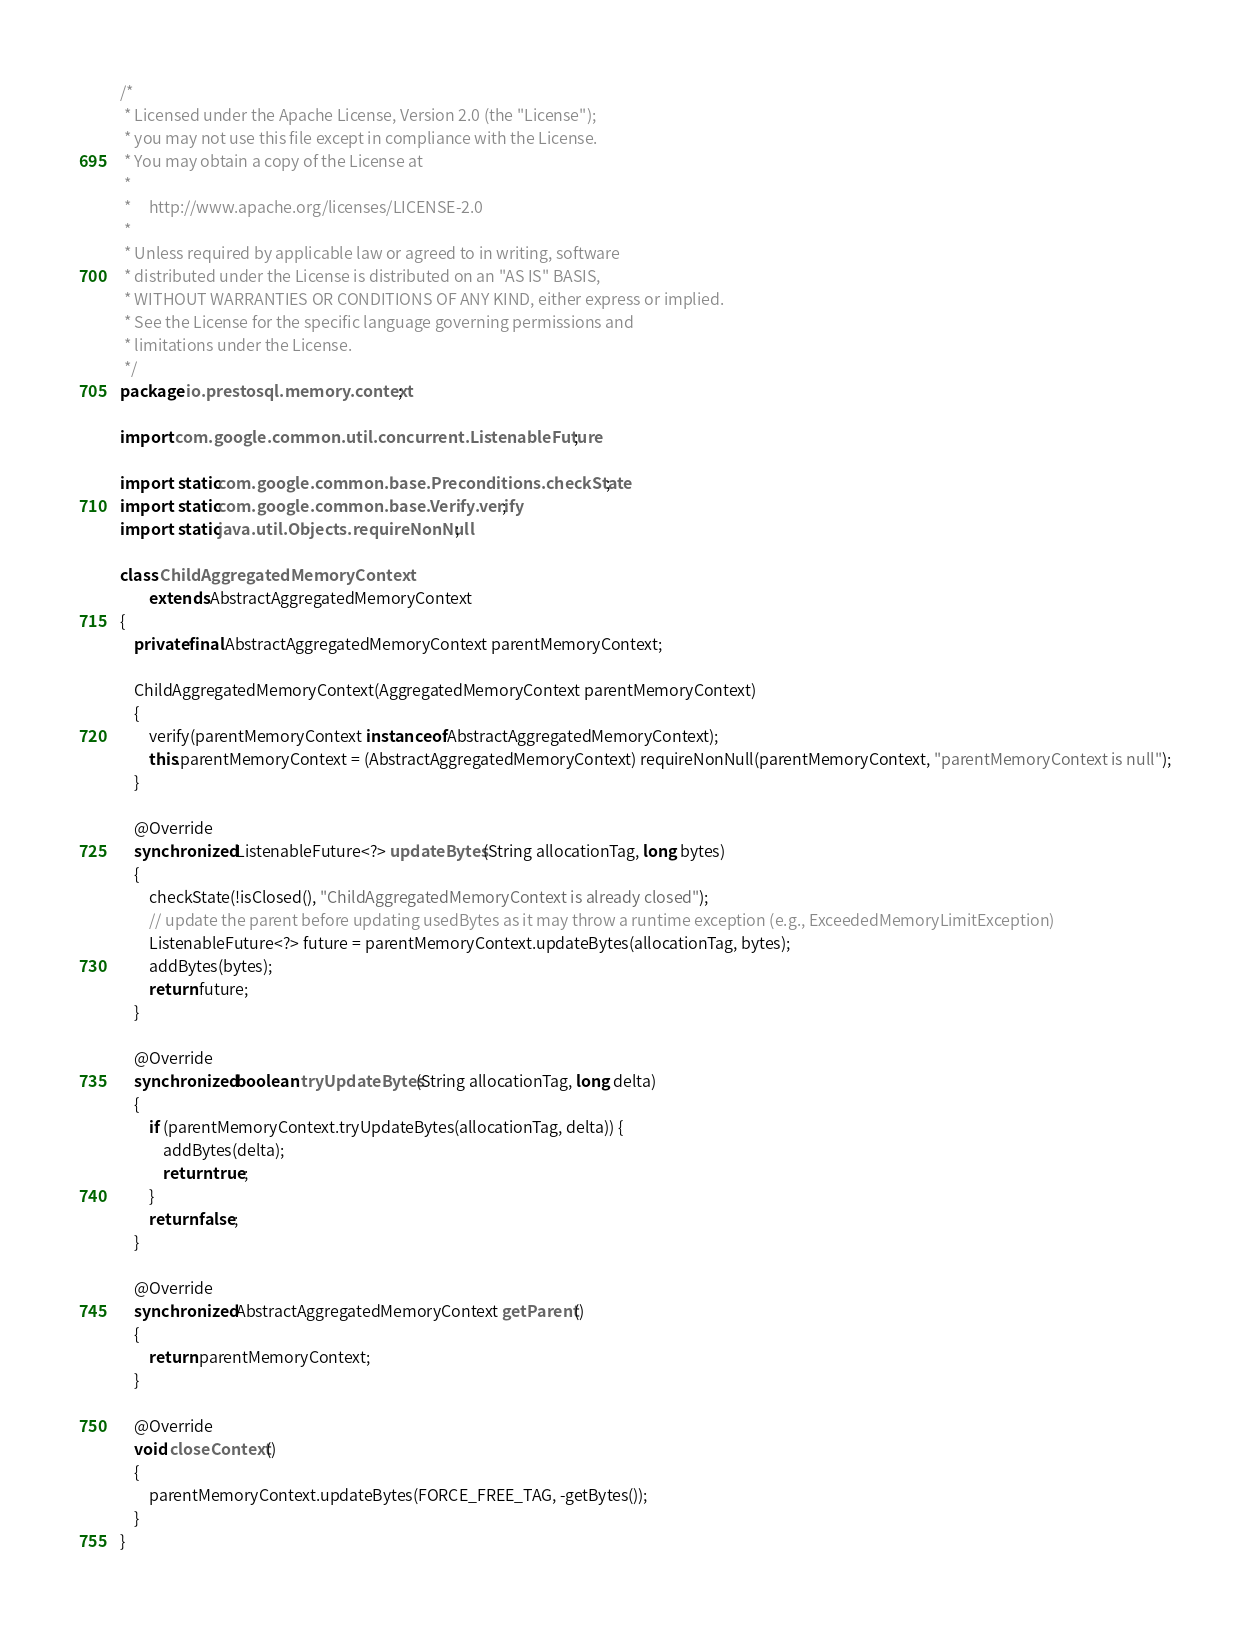Convert code to text. <code><loc_0><loc_0><loc_500><loc_500><_Java_>/*
 * Licensed under the Apache License, Version 2.0 (the "License");
 * you may not use this file except in compliance with the License.
 * You may obtain a copy of the License at
 *
 *     http://www.apache.org/licenses/LICENSE-2.0
 *
 * Unless required by applicable law or agreed to in writing, software
 * distributed under the License is distributed on an "AS IS" BASIS,
 * WITHOUT WARRANTIES OR CONDITIONS OF ANY KIND, either express or implied.
 * See the License for the specific language governing permissions and
 * limitations under the License.
 */
package io.prestosql.memory.context;

import com.google.common.util.concurrent.ListenableFuture;

import static com.google.common.base.Preconditions.checkState;
import static com.google.common.base.Verify.verify;
import static java.util.Objects.requireNonNull;

class ChildAggregatedMemoryContext
        extends AbstractAggregatedMemoryContext
{
    private final AbstractAggregatedMemoryContext parentMemoryContext;

    ChildAggregatedMemoryContext(AggregatedMemoryContext parentMemoryContext)
    {
        verify(parentMemoryContext instanceof AbstractAggregatedMemoryContext);
        this.parentMemoryContext = (AbstractAggregatedMemoryContext) requireNonNull(parentMemoryContext, "parentMemoryContext is null");
    }

    @Override
    synchronized ListenableFuture<?> updateBytes(String allocationTag, long bytes)
    {
        checkState(!isClosed(), "ChildAggregatedMemoryContext is already closed");
        // update the parent before updating usedBytes as it may throw a runtime exception (e.g., ExceededMemoryLimitException)
        ListenableFuture<?> future = parentMemoryContext.updateBytes(allocationTag, bytes);
        addBytes(bytes);
        return future;
    }

    @Override
    synchronized boolean tryUpdateBytes(String allocationTag, long delta)
    {
        if (parentMemoryContext.tryUpdateBytes(allocationTag, delta)) {
            addBytes(delta);
            return true;
        }
        return false;
    }

    @Override
    synchronized AbstractAggregatedMemoryContext getParent()
    {
        return parentMemoryContext;
    }

    @Override
    void closeContext()
    {
        parentMemoryContext.updateBytes(FORCE_FREE_TAG, -getBytes());
    }
}
</code> 